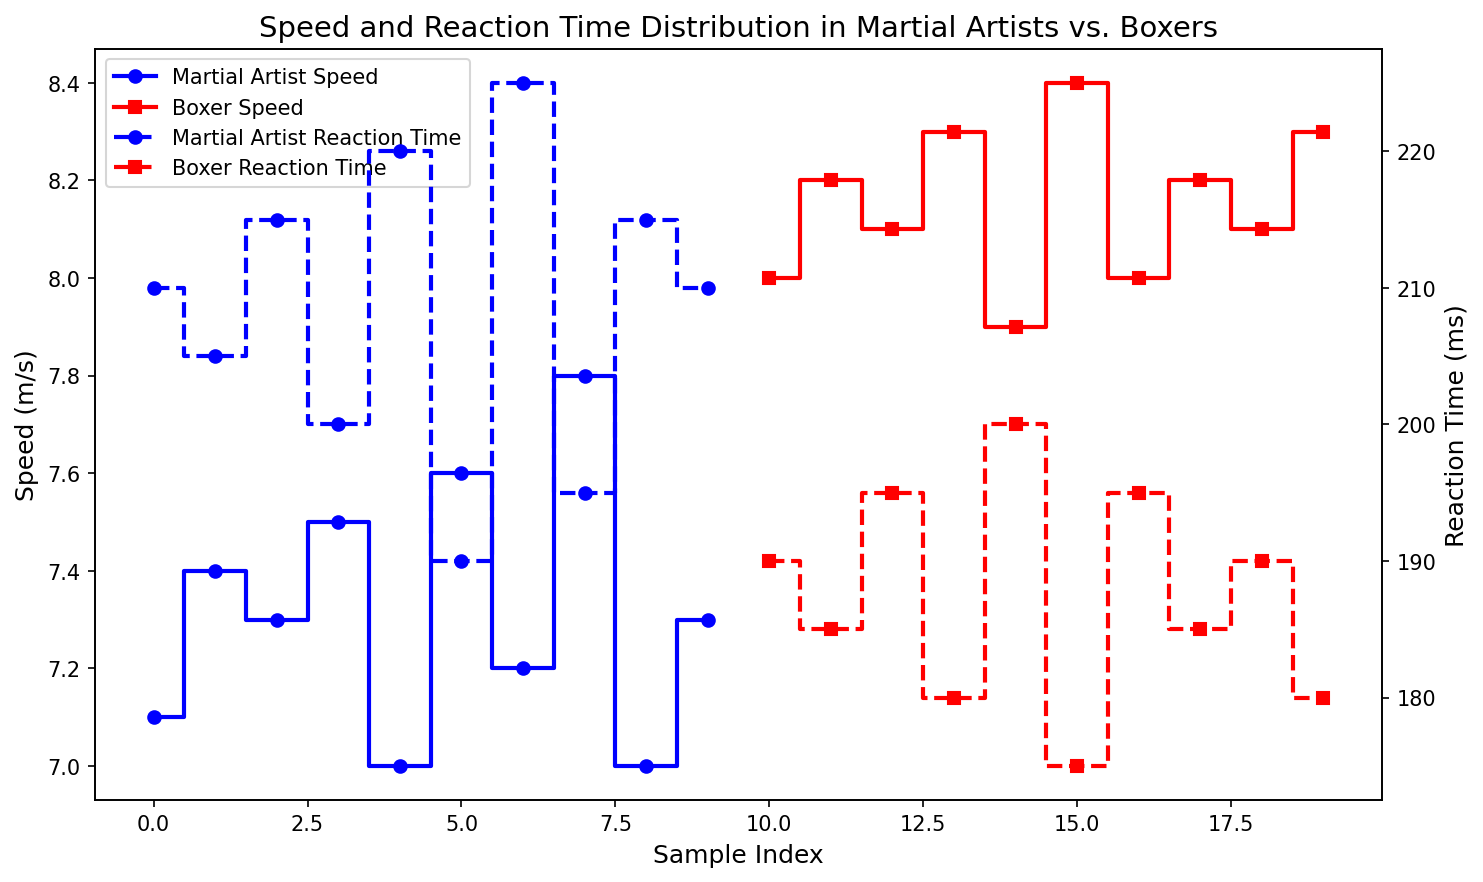What is the difference in average speed between Martial Artists and Boxers? To find the difference in average speed, first, calculate the average speed for both groups. Average speed for Martial Artists = (7.1 + 7.4 + 7.3 + 7.5 + 7.0 + 7.6 + 7.2 + 7.8 + 7.0 + 7.3) / 10 = 7.32 m/s. Average speed for Boxers = (8.0 + 8.2 + 8.1 + 8.3 + 7.9 + 8.4 + 8.0 + 8.2 + 8.1 + 8.3) / 10 = 8.15 m/s. The difference is 8.15 - 7.32 = 0.83 m/s
Answer: 0.83 m/s Which group has consistently lower reaction times? By looking at the plot, we see that the reaction times for Boxers are visually lower compared to Martial Artists throughout the index range. This is indicated by the dashed red lines being consistently lower on the y-axis.
Answer: Boxers What is the visual difference in the markers used for Martial Artists and Boxers? The plot shows that the markers for Martial Artists are represented by circles, while those for Boxers are represented by squares. This helps differentiate the two groups visually.
Answer: Circles and Squares On which index do the Boxers have their highest speed, and what is that speed? The highest speed for Boxers can be visually identified on the step plot, where boxes reach their peak. This highest speed occurs on multiple indices: 5 and 9, where the speed is 8.4 m/s.
Answer: Indices 5 and 9, Speed 8.4 m/s Between the speed and reaction time of Martial Artists at index 3, which one is higher relative to their respective scales? From the plot, the speed at index 3 for Martial Artists is 7.5 m/s. The reaction time at the same index is 200 ms. Visually comparing the scales, the speed is nearer to the higher end of its scale compared to the reaction time.
Answer: Speed (7.5 m/s) What is the general trend in reaction times for Martial Artists as the index increases? By observing the plot, the reaction times for Martial Artists show a decreasing trend as indicated by the dashed blue line which moves downward as the index increases.
Answer: Decreasing trend Are there any overlap points in speed between Martial Artists and Boxers? From the plot, we notice that the speeds of Martial Artists and Boxers both frequently lie in the range of approximately 7.0 to 7.8 m/s, suggesting overlaps at certain indices.
Answer: Yes What is the minimum reaction time observed for Boxers and on what index does it occur? Observing the dashed red line for reaction times, the minimum reaction time for Boxers is 175 ms which occurs at index 5.
Answer: 175 ms, Index 5 What is the average reaction time for Martial Artists? Calculate the average reaction time for Martial Artists: (210 + 205 + 215 + 200 + 220 + 190 + 225 + 195 + 215 + 210) / 10 = 208.5 ms
Answer: 208.5 ms How many indices do both groups have where their speeds exceed 7.5 m/s? From the plot, check the points where speed exceeds 7.5 m/s for both groups. Martial Artists exceed 7.5 m/s at indices 7 and 11 for a total of 2. Boxers exceed 7.5 m/s consistently from indices 1 to 9 except for index 5, totaling 9 indices.
Answer: Martial Artists: 2, Boxers: 9 